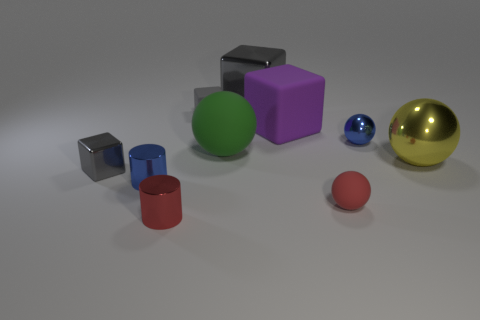Do the blue metallic thing behind the tiny metal cube and the large object in front of the large green ball have the same shape?
Ensure brevity in your answer.  Yes. Is the number of small gray matte blocks on the left side of the tiny red matte sphere the same as the number of gray metallic blocks behind the tiny matte cube?
Your answer should be compact. Yes. What is the shape of the gray metal thing that is right of the small cylinder that is on the left side of the shiny cylinder that is in front of the small blue cylinder?
Your response must be concise. Cube. Is the material of the red object to the left of the big gray cube the same as the tiny gray cube that is behind the large yellow metallic thing?
Your response must be concise. No. What shape is the blue thing that is behind the big green rubber ball?
Your answer should be compact. Sphere. Is the number of big yellow balls less than the number of brown rubber things?
Make the answer very short. No. There is a large sphere to the right of the blue metallic thing to the right of the big gray cube; is there a large matte object that is right of it?
Make the answer very short. No. How many metallic things are large purple things or small cylinders?
Keep it short and to the point. 2. Do the tiny rubber block and the large metallic block have the same color?
Make the answer very short. Yes. There is a large purple rubber cube; how many small rubber things are left of it?
Provide a short and direct response. 1. 